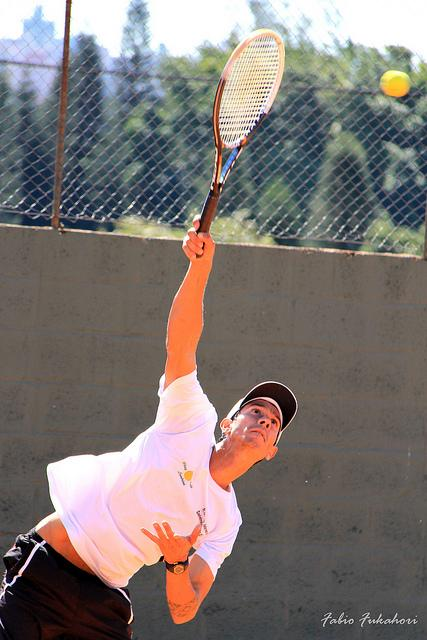What is his wrist accessory used for? Please explain your reasoning. tell time. The accessory is for telling time. 